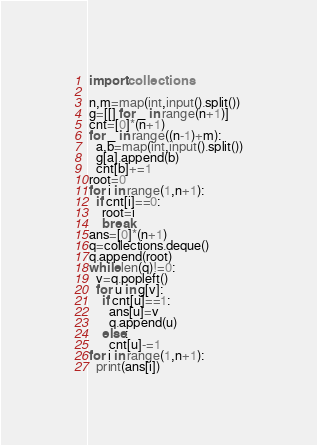<code> <loc_0><loc_0><loc_500><loc_500><_Python_>import collections

n,m=map(int,input().split())
g=[[] for _ in range(n+1)]
cnt=[0]*(n+1)
for _ in range((n-1)+m):
  a,b=map(int,input().split())
  g[a].append(b)
  cnt[b]+=1
root=0
for i in range(1,n+1):
  if cnt[i]==0:
    root=i
    break
ans=[0]*(n+1)
q=collections.deque()
q.append(root)
while len(q)!=0:
  v=q.popleft()
  for u in g[v]:
    if cnt[u]==1:
      ans[u]=v
      q.append(u)
    else:
      cnt[u]-=1
for i in range(1,n+1):
  print(ans[i])</code> 